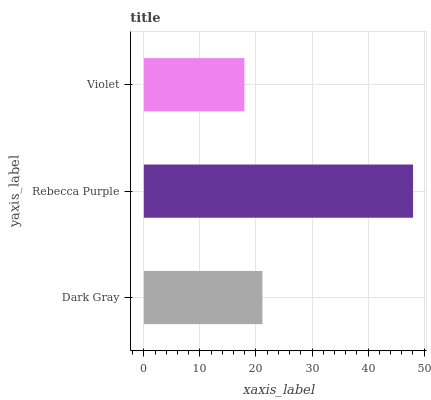Is Violet the minimum?
Answer yes or no. Yes. Is Rebecca Purple the maximum?
Answer yes or no. Yes. Is Rebecca Purple the minimum?
Answer yes or no. No. Is Violet the maximum?
Answer yes or no. No. Is Rebecca Purple greater than Violet?
Answer yes or no. Yes. Is Violet less than Rebecca Purple?
Answer yes or no. Yes. Is Violet greater than Rebecca Purple?
Answer yes or no. No. Is Rebecca Purple less than Violet?
Answer yes or no. No. Is Dark Gray the high median?
Answer yes or no. Yes. Is Dark Gray the low median?
Answer yes or no. Yes. Is Violet the high median?
Answer yes or no. No. Is Rebecca Purple the low median?
Answer yes or no. No. 